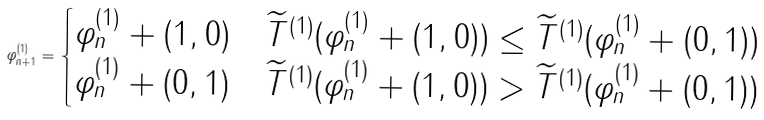Convert formula to latex. <formula><loc_0><loc_0><loc_500><loc_500>\varphi _ { n + 1 } ^ { ( 1 ) } = \begin{cases} \varphi _ { n } ^ { ( 1 ) } + ( 1 , 0 ) & \widetilde { T } ^ { ( 1 ) } ( \varphi _ { n } ^ { ( 1 ) } + ( 1 , 0 ) ) \leq \widetilde { T } ^ { ( 1 ) } ( \varphi _ { n } ^ { ( 1 ) } + ( 0 , 1 ) ) \\ \varphi _ { n } ^ { ( 1 ) } + ( 0 , 1 ) & \widetilde { T } ^ { ( 1 ) } ( \varphi _ { n } ^ { ( 1 ) } + ( 1 , 0 ) ) > \widetilde { T } ^ { ( 1 ) } ( \varphi _ { n } ^ { ( 1 ) } + ( 0 , 1 ) ) \end{cases}</formula> 